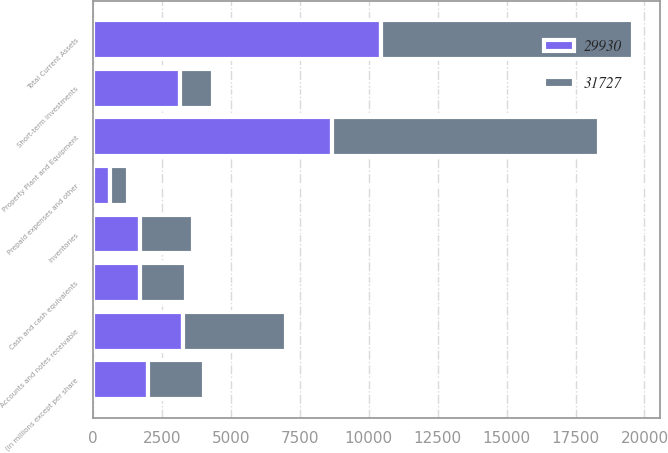<chart> <loc_0><loc_0><loc_500><loc_500><stacked_bar_chart><ecel><fcel>(in millions except per share<fcel>Cash and cash equivalents<fcel>Short-term investments<fcel>Accounts and notes receivable<fcel>Inventories<fcel>Prepaid expenses and other<fcel>Total Current Assets<fcel>Property Plant and Equipment<nl><fcel>31727<fcel>2006<fcel>1651<fcel>1171<fcel>3725<fcel>1926<fcel>657<fcel>9130<fcel>9687<nl><fcel>29930<fcel>2005<fcel>1716<fcel>3166<fcel>3261<fcel>1693<fcel>618<fcel>10454<fcel>8681<nl></chart> 